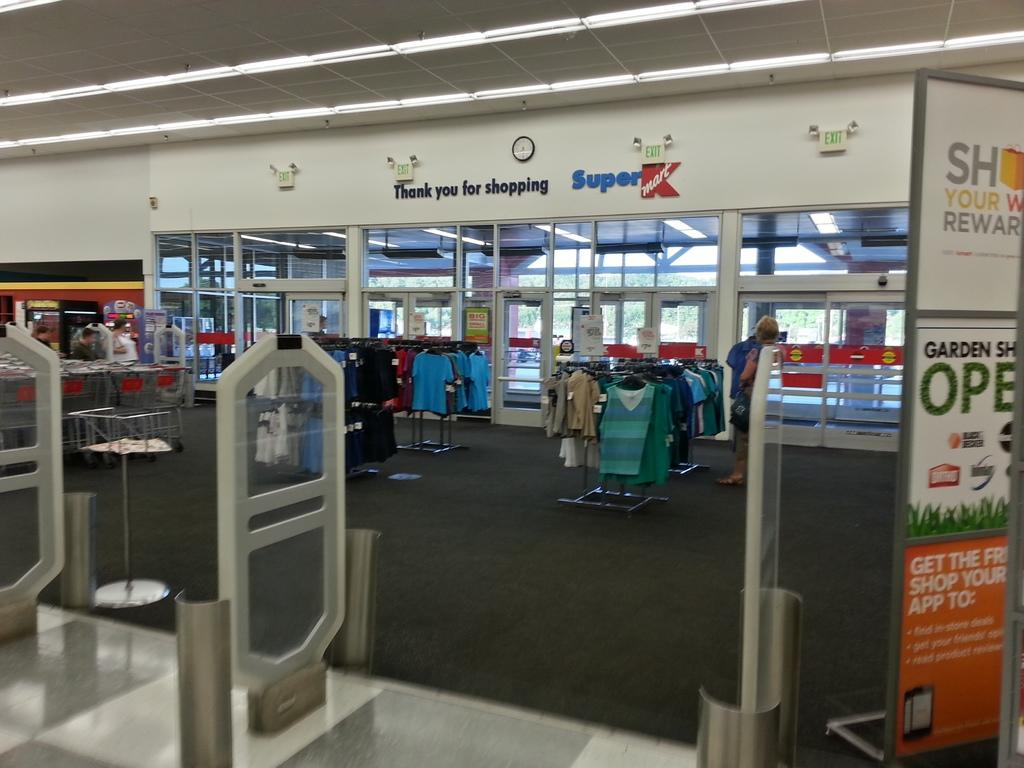<image>
Describe the image concisely. The exit to Super Kmart, including the safety rails you must pass. 